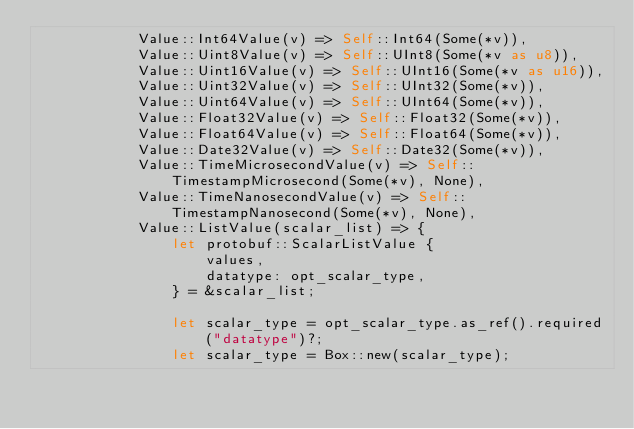Convert code to text. <code><loc_0><loc_0><loc_500><loc_500><_Rust_>            Value::Int64Value(v) => Self::Int64(Some(*v)),
            Value::Uint8Value(v) => Self::UInt8(Some(*v as u8)),
            Value::Uint16Value(v) => Self::UInt16(Some(*v as u16)),
            Value::Uint32Value(v) => Self::UInt32(Some(*v)),
            Value::Uint64Value(v) => Self::UInt64(Some(*v)),
            Value::Float32Value(v) => Self::Float32(Some(*v)),
            Value::Float64Value(v) => Self::Float64(Some(*v)),
            Value::Date32Value(v) => Self::Date32(Some(*v)),
            Value::TimeMicrosecondValue(v) => Self::TimestampMicrosecond(Some(*v), None),
            Value::TimeNanosecondValue(v) => Self::TimestampNanosecond(Some(*v), None),
            Value::ListValue(scalar_list) => {
                let protobuf::ScalarListValue {
                    values,
                    datatype: opt_scalar_type,
                } = &scalar_list;

                let scalar_type = opt_scalar_type.as_ref().required("datatype")?;
                let scalar_type = Box::new(scalar_type);
</code> 